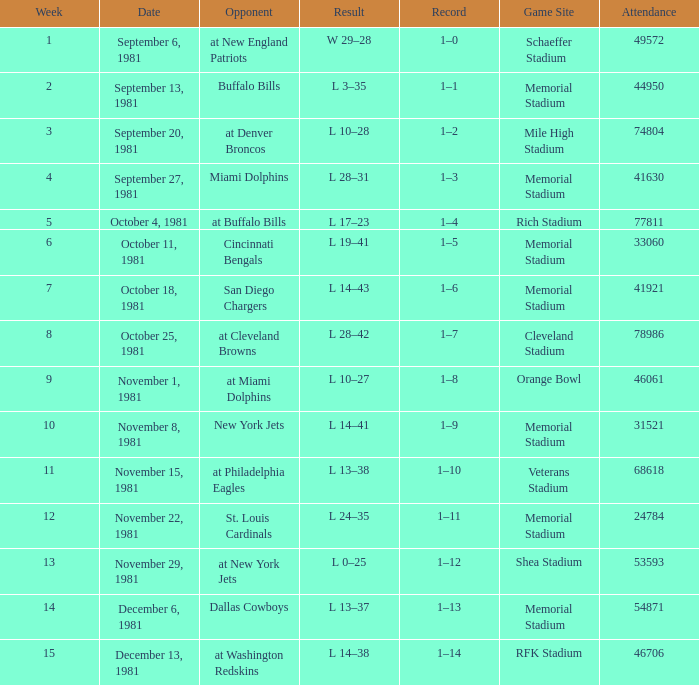During week 2, what is the performance? 1–1. 